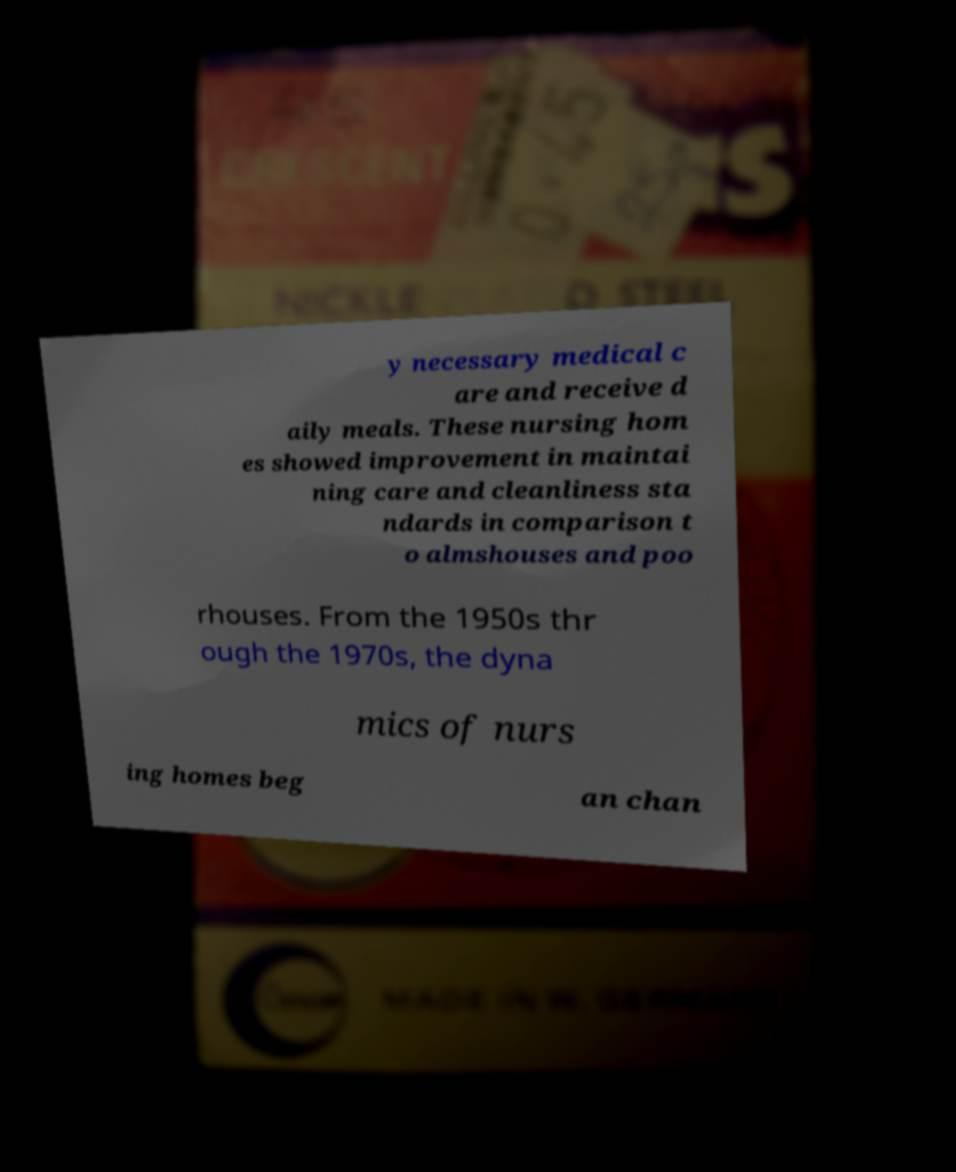There's text embedded in this image that I need extracted. Can you transcribe it verbatim? y necessary medical c are and receive d aily meals. These nursing hom es showed improvement in maintai ning care and cleanliness sta ndards in comparison t o almshouses and poo rhouses. From the 1950s thr ough the 1970s, the dyna mics of nurs ing homes beg an chan 